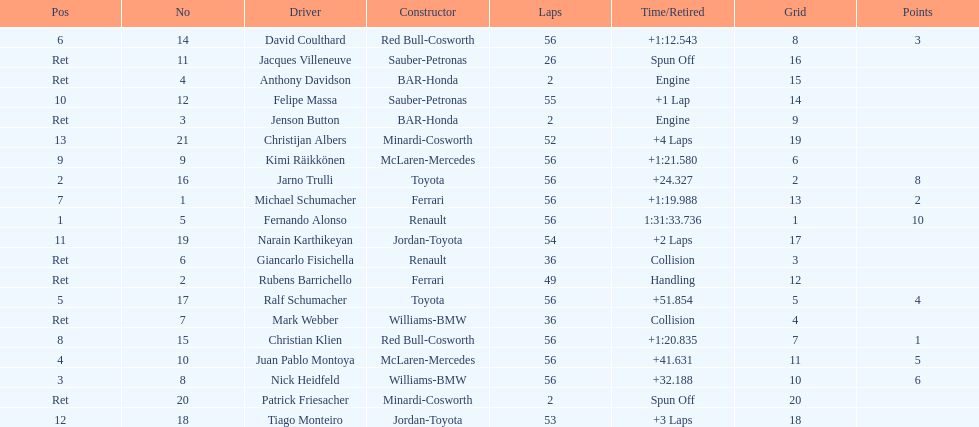What driver finished first? Fernando Alonso. 